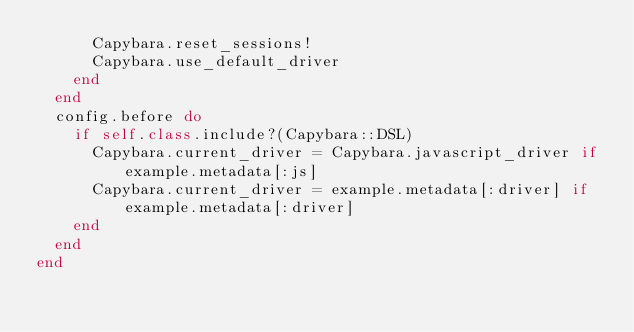<code> <loc_0><loc_0><loc_500><loc_500><_Ruby_>      Capybara.reset_sessions!
      Capybara.use_default_driver
    end
  end
  config.before do
    if self.class.include?(Capybara::DSL)
      Capybara.current_driver = Capybara.javascript_driver if example.metadata[:js]
      Capybara.current_driver = example.metadata[:driver] if example.metadata[:driver]
    end
  end
end
</code> 